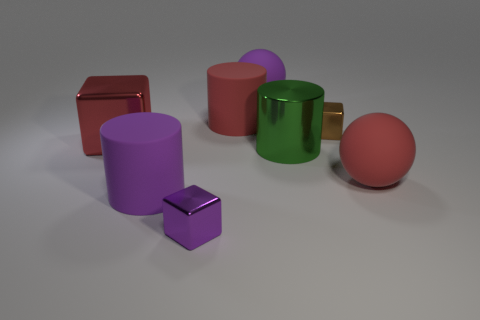Are there any patterns or themes that these objects might represent? While there isn't an explicit pattern or theme present, the collection of objects could be interpreted as a study in contrasts—between shiny and matte surfaces, geometric shapes like the sphere, cube, and cylinder, as well as the contrast between functionality and form as seen with the decorative green mug and the simple geometric blocks. 